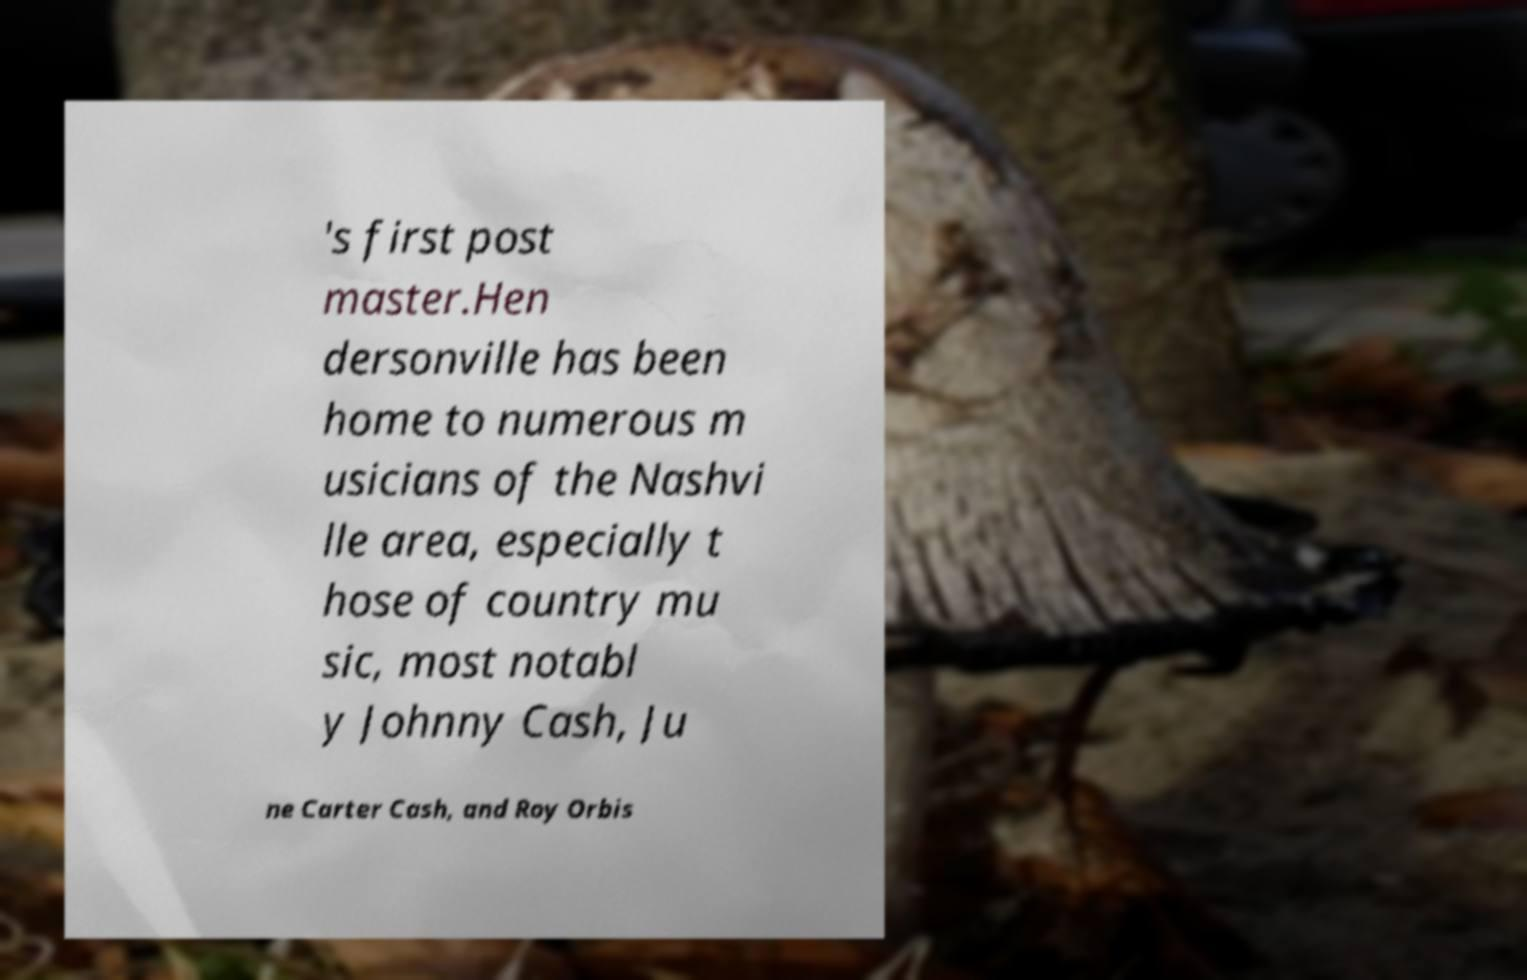I need the written content from this picture converted into text. Can you do that? 's first post master.Hen dersonville has been home to numerous m usicians of the Nashvi lle area, especially t hose of country mu sic, most notabl y Johnny Cash, Ju ne Carter Cash, and Roy Orbis 